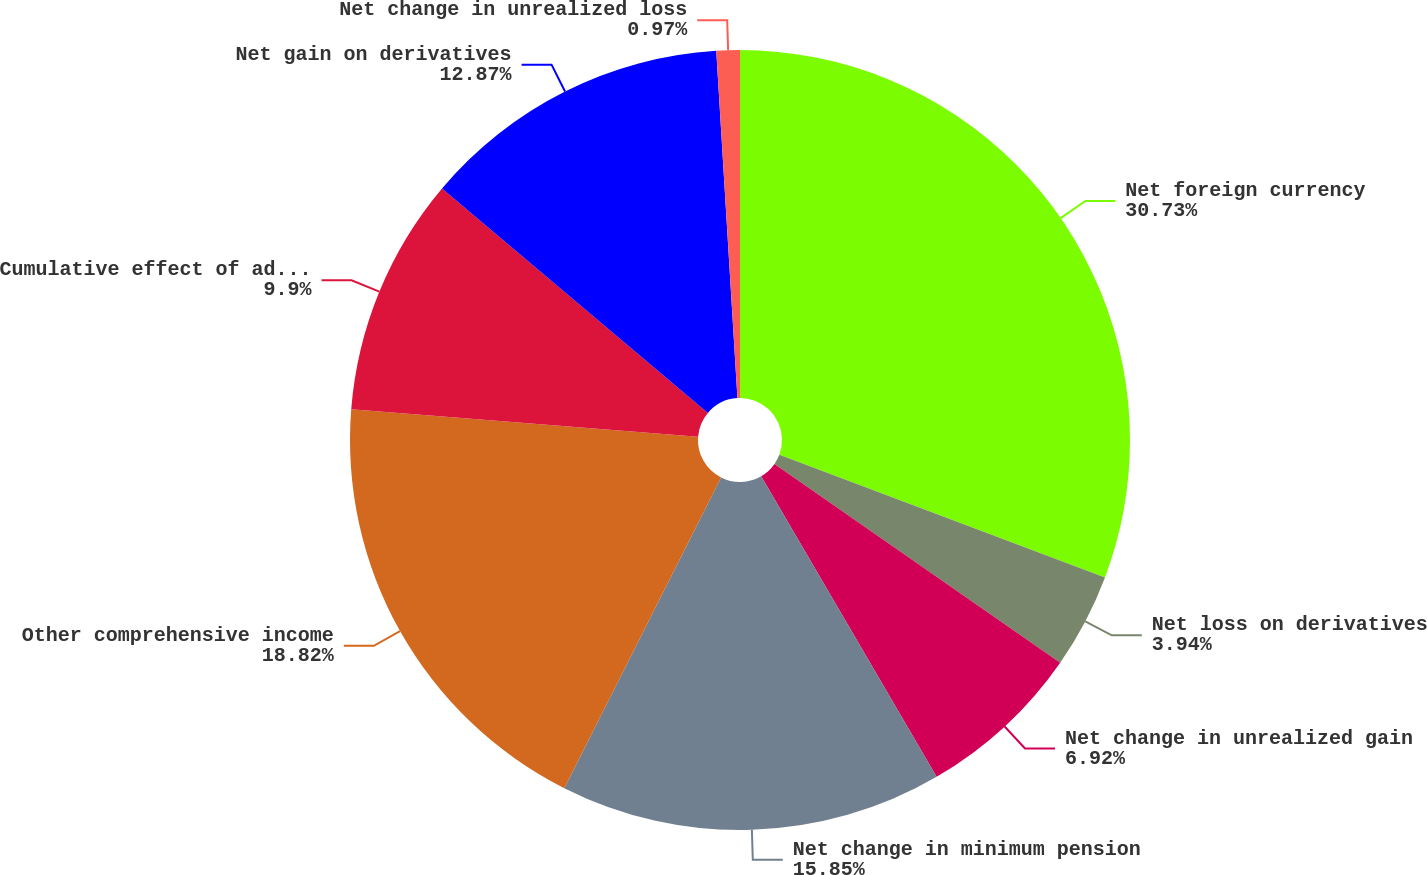Convert chart to OTSL. <chart><loc_0><loc_0><loc_500><loc_500><pie_chart><fcel>Net foreign currency<fcel>Net loss on derivatives<fcel>Net change in unrealized gain<fcel>Net change in minimum pension<fcel>Other comprehensive income<fcel>Cumulative effect of adopting<fcel>Net gain on derivatives<fcel>Net change in unrealized loss<nl><fcel>30.73%<fcel>3.94%<fcel>6.92%<fcel>15.85%<fcel>18.82%<fcel>9.9%<fcel>12.87%<fcel>0.97%<nl></chart> 